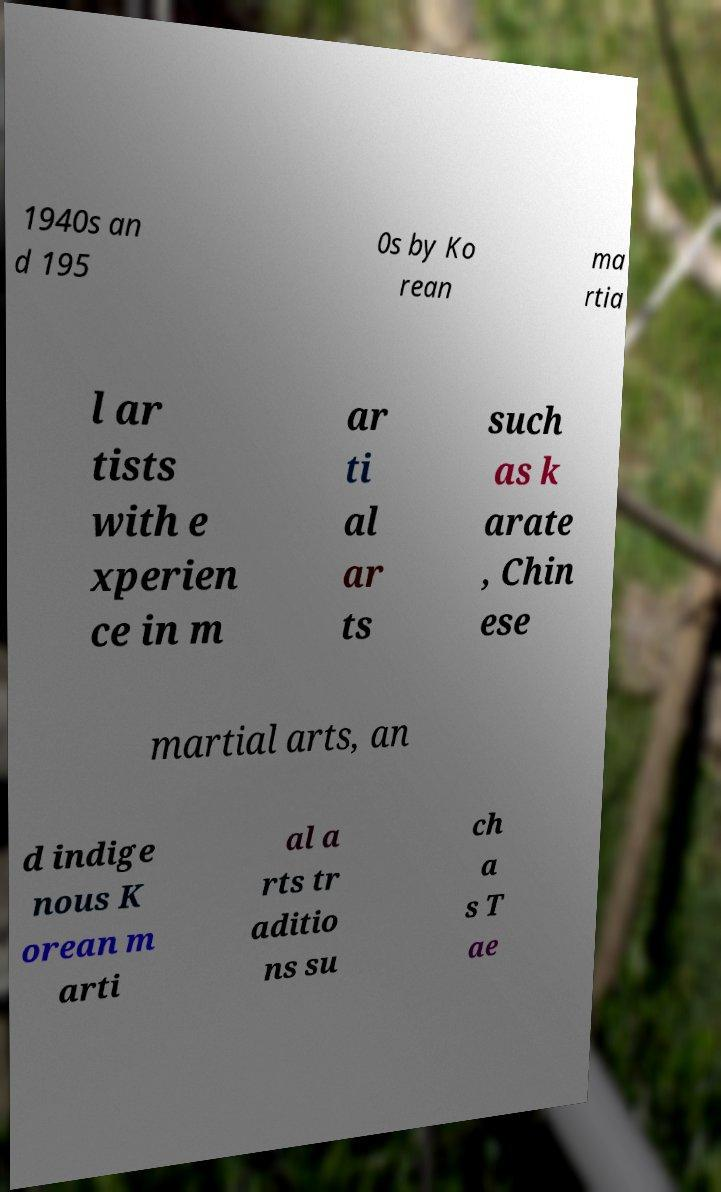Please read and relay the text visible in this image. What does it say? 1940s an d 195 0s by Ko rean ma rtia l ar tists with e xperien ce in m ar ti al ar ts such as k arate , Chin ese martial arts, an d indige nous K orean m arti al a rts tr aditio ns su ch a s T ae 